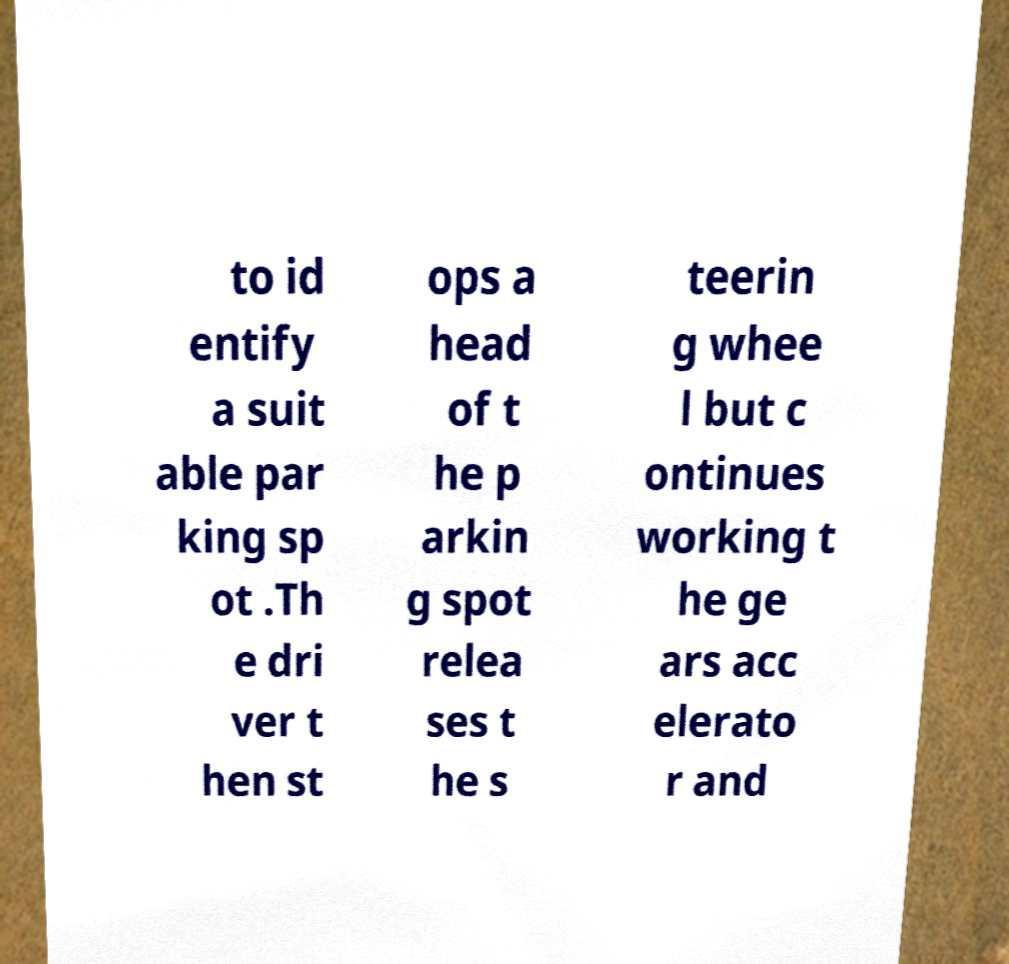Can you read and provide the text displayed in the image?This photo seems to have some interesting text. Can you extract and type it out for me? to id entify a suit able par king sp ot .Th e dri ver t hen st ops a head of t he p arkin g spot relea ses t he s teerin g whee l but c ontinues working t he ge ars acc elerato r and 